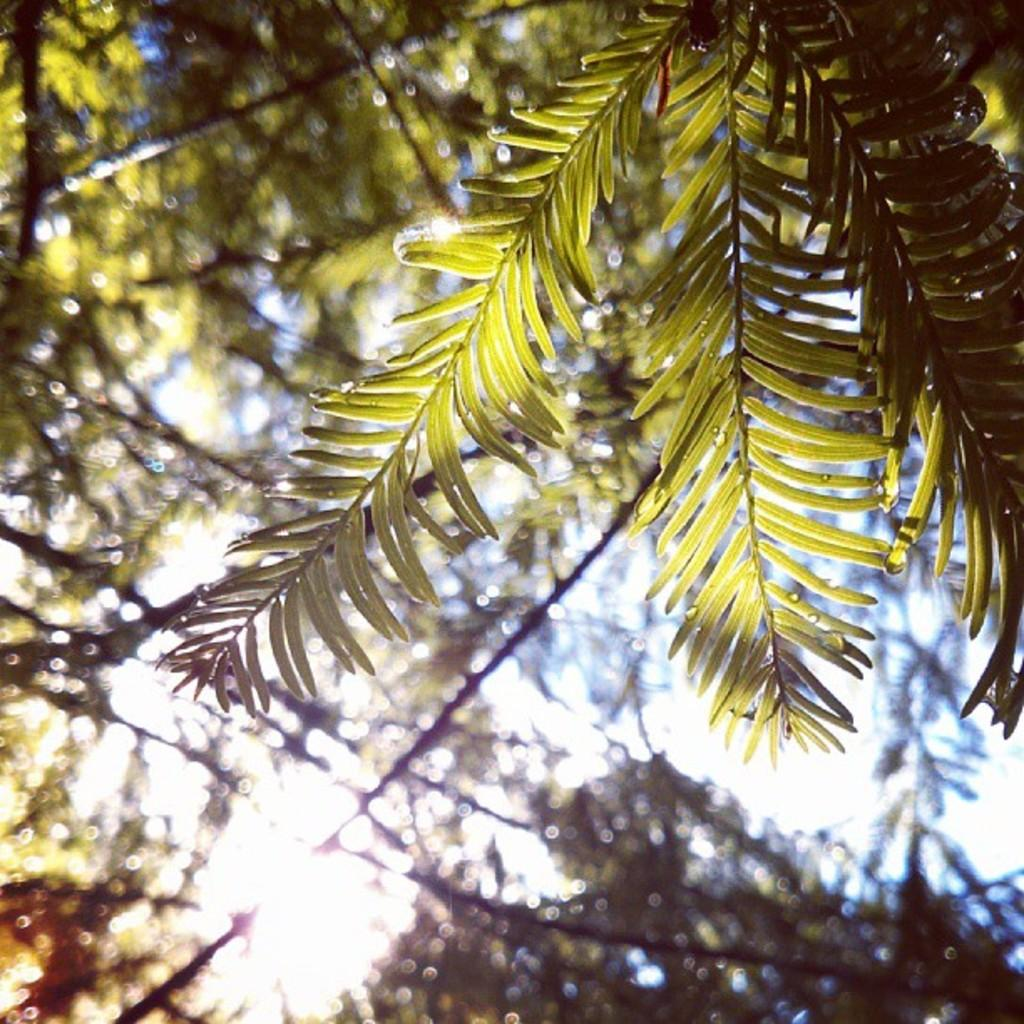What is in the foreground of the image? There are leaves of a tree in the foreground of the image. What can be seen in the background of the image? There is a tree and the sky visible in the background of the image. What type of card can be seen in the morning in the image? There is no card present in the image, and the time of day is not mentioned, so it cannot be determined if the image represents morning. 